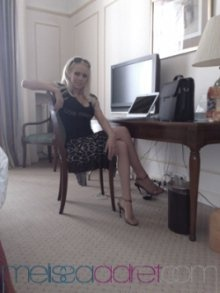Describe the objects in this image and their specific colors. I can see people in gray, black, and darkgray tones, tv in gray, white, and darkgray tones, chair in gray and black tones, handbag in gray and black tones, and chair in gray and black tones in this image. 